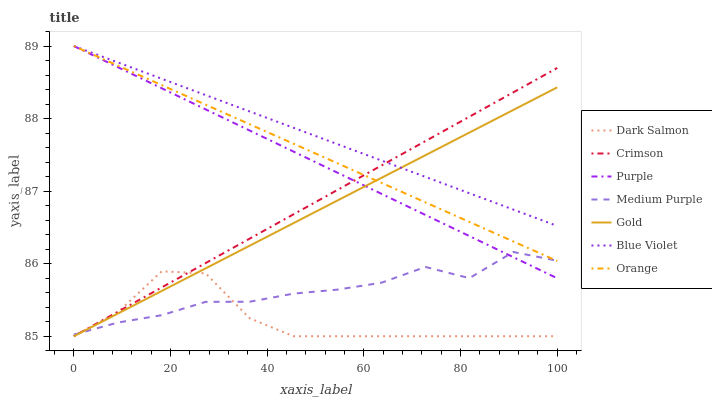Does Dark Salmon have the minimum area under the curve?
Answer yes or no. Yes. Does Blue Violet have the maximum area under the curve?
Answer yes or no. Yes. Does Purple have the minimum area under the curve?
Answer yes or no. No. Does Purple have the maximum area under the curve?
Answer yes or no. No. Is Crimson the smoothest?
Answer yes or no. Yes. Is Dark Salmon the roughest?
Answer yes or no. Yes. Is Purple the smoothest?
Answer yes or no. No. Is Purple the roughest?
Answer yes or no. No. Does Gold have the lowest value?
Answer yes or no. Yes. Does Purple have the lowest value?
Answer yes or no. No. Does Blue Violet have the highest value?
Answer yes or no. Yes. Does Dark Salmon have the highest value?
Answer yes or no. No. Is Dark Salmon less than Purple?
Answer yes or no. Yes. Is Blue Violet greater than Dark Salmon?
Answer yes or no. Yes. Does Gold intersect Dark Salmon?
Answer yes or no. Yes. Is Gold less than Dark Salmon?
Answer yes or no. No. Is Gold greater than Dark Salmon?
Answer yes or no. No. Does Dark Salmon intersect Purple?
Answer yes or no. No. 